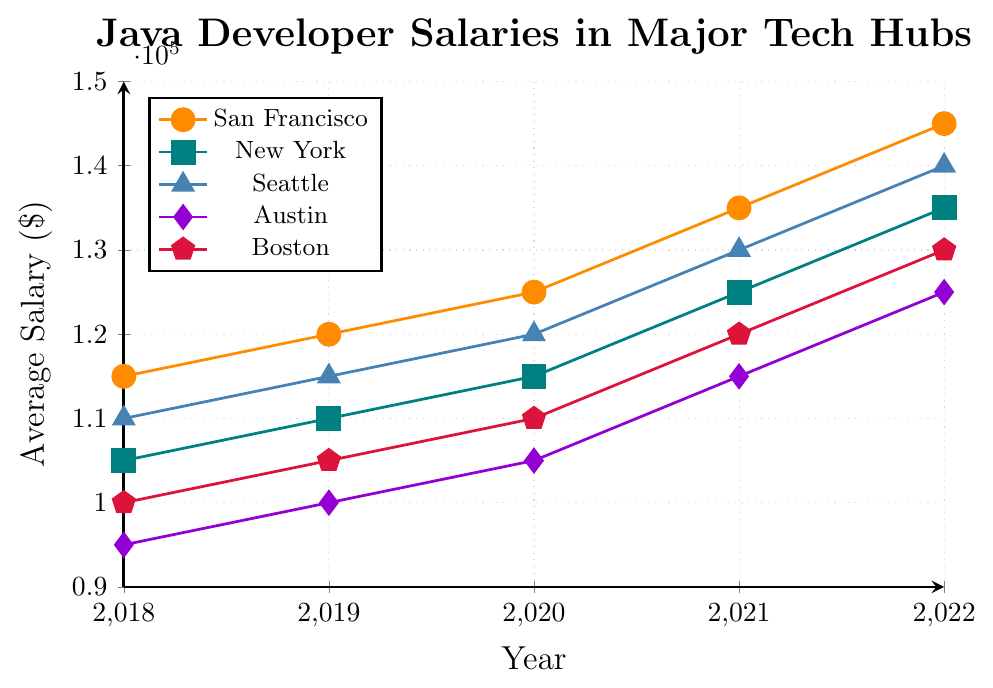What is the average salary for a Java developer in New York over the last 5 years? Average = (105,000 + 110,000 + 115,000 + 125,000 + 135,000) / 5. Summing the values = 590,000. Dividing by 5 = 118,000
Answer: 118,000 Which city had the highest salary for Java developers in 2022? Look at the y-values for 2022 for all cities. San Francisco has the highest salary at 145,000
Answer: San Francisco How much did the average salary for Java developers increase in Seattle from 2018 to 2022? Subtract the 2018 value from the 2022 value for Seattle. 140,000 (2022) - 110,000 (2018) = 30,000
Answer: 30,000 Which city showed the greatest salary growth from 2018 to 2022? Calculate the growth for each city: 
San Francisco: 145,000 - 115,000 = 30,000 
New York: 135,000 - 105,000 = 30,000 
Seattle: 140,000 - 110,000 = 30,000 
Austin: 125,000 - 95,000 = 30,000 
Boston: 130,000 - 100,000 = 30,000 
All cities had the same growth of 30,000.
Answer: San Francisco, New York, Seattle, Austin, Boston What was the combined total salary for Java developers in Boston and Austin in 2021? Sum the salaries for Boston and Austin in 2021. 115,000 (Austin) + 120,000 (Boston) = 235,000
Answer: 235,000 Which city had the lowest salary for Java developers in 2020? Look at the y-values for 2020 for all cities. Austin has the lowest salary at 105,000
Answer: Austin Did any city's salary decline in any year? Observe the salary trends over the years for all cities. All cities show an increasing trend, no decline
Answer: No How does the salary trend in Boston compare to the trend in New York from 2018 to 2022? Compare the slopes of the lines for Boston and New York. Both cities' salaries are increasing, with New York having a slightly higher final salary in 2022 compared to Boston. The pattern is similar with slight variations in magnitude
Answer: Similar trend with higher final salary for New York What's the difference in salary between the highest and lowest paying cities in 2022? Find the highest salary in 2022 (San Francisco at 145,000) and the lowest salary in 2022 (Austin at 125,000). Subtract the lowest from the highest. 145,000 - 125,000 = 20,000
Answer: 20,000 